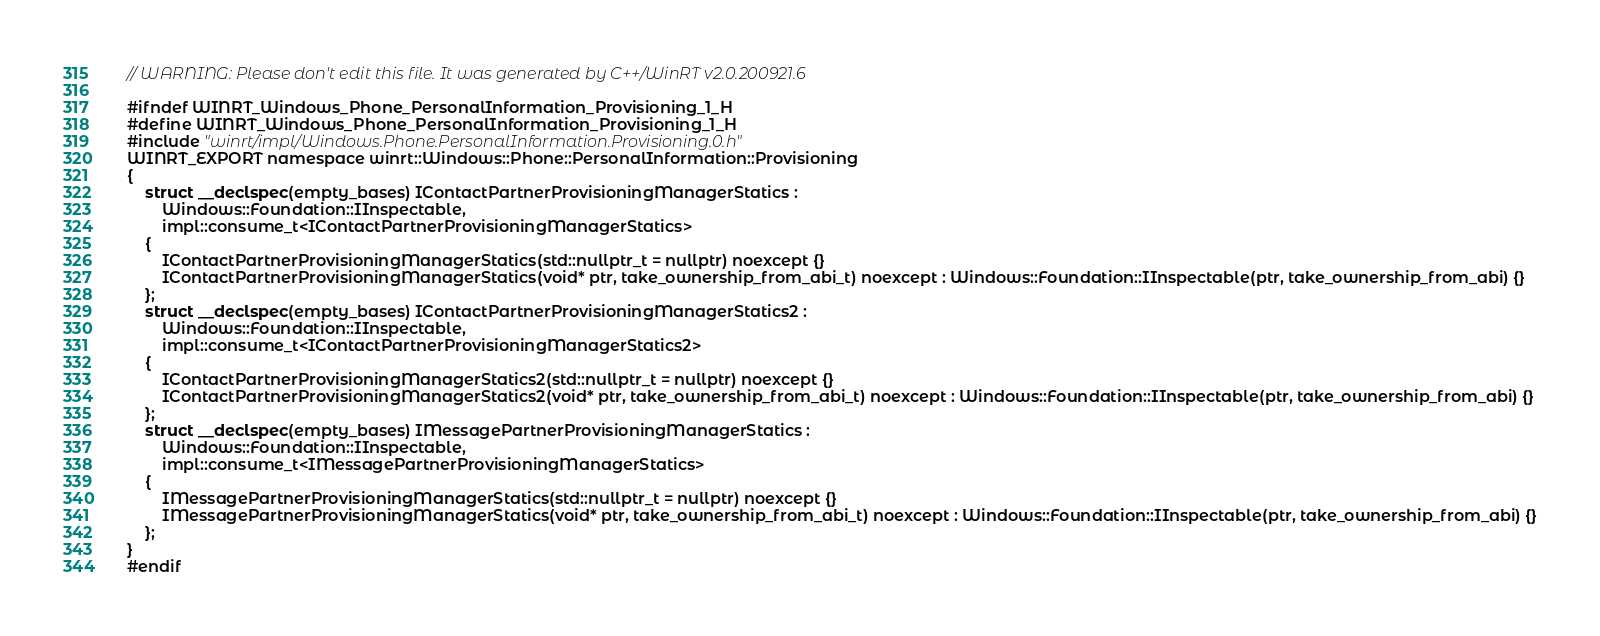<code> <loc_0><loc_0><loc_500><loc_500><_C_>// WARNING: Please don't edit this file. It was generated by C++/WinRT v2.0.200921.6

#ifndef WINRT_Windows_Phone_PersonalInformation_Provisioning_1_H
#define WINRT_Windows_Phone_PersonalInformation_Provisioning_1_H
#include "winrt/impl/Windows.Phone.PersonalInformation.Provisioning.0.h"
WINRT_EXPORT namespace winrt::Windows::Phone::PersonalInformation::Provisioning
{
    struct __declspec(empty_bases) IContactPartnerProvisioningManagerStatics :
        Windows::Foundation::IInspectable,
        impl::consume_t<IContactPartnerProvisioningManagerStatics>
    {
        IContactPartnerProvisioningManagerStatics(std::nullptr_t = nullptr) noexcept {}
        IContactPartnerProvisioningManagerStatics(void* ptr, take_ownership_from_abi_t) noexcept : Windows::Foundation::IInspectable(ptr, take_ownership_from_abi) {}
    };
    struct __declspec(empty_bases) IContactPartnerProvisioningManagerStatics2 :
        Windows::Foundation::IInspectable,
        impl::consume_t<IContactPartnerProvisioningManagerStatics2>
    {
        IContactPartnerProvisioningManagerStatics2(std::nullptr_t = nullptr) noexcept {}
        IContactPartnerProvisioningManagerStatics2(void* ptr, take_ownership_from_abi_t) noexcept : Windows::Foundation::IInspectable(ptr, take_ownership_from_abi) {}
    };
    struct __declspec(empty_bases) IMessagePartnerProvisioningManagerStatics :
        Windows::Foundation::IInspectable,
        impl::consume_t<IMessagePartnerProvisioningManagerStatics>
    {
        IMessagePartnerProvisioningManagerStatics(std::nullptr_t = nullptr) noexcept {}
        IMessagePartnerProvisioningManagerStatics(void* ptr, take_ownership_from_abi_t) noexcept : Windows::Foundation::IInspectable(ptr, take_ownership_from_abi) {}
    };
}
#endif
</code> 